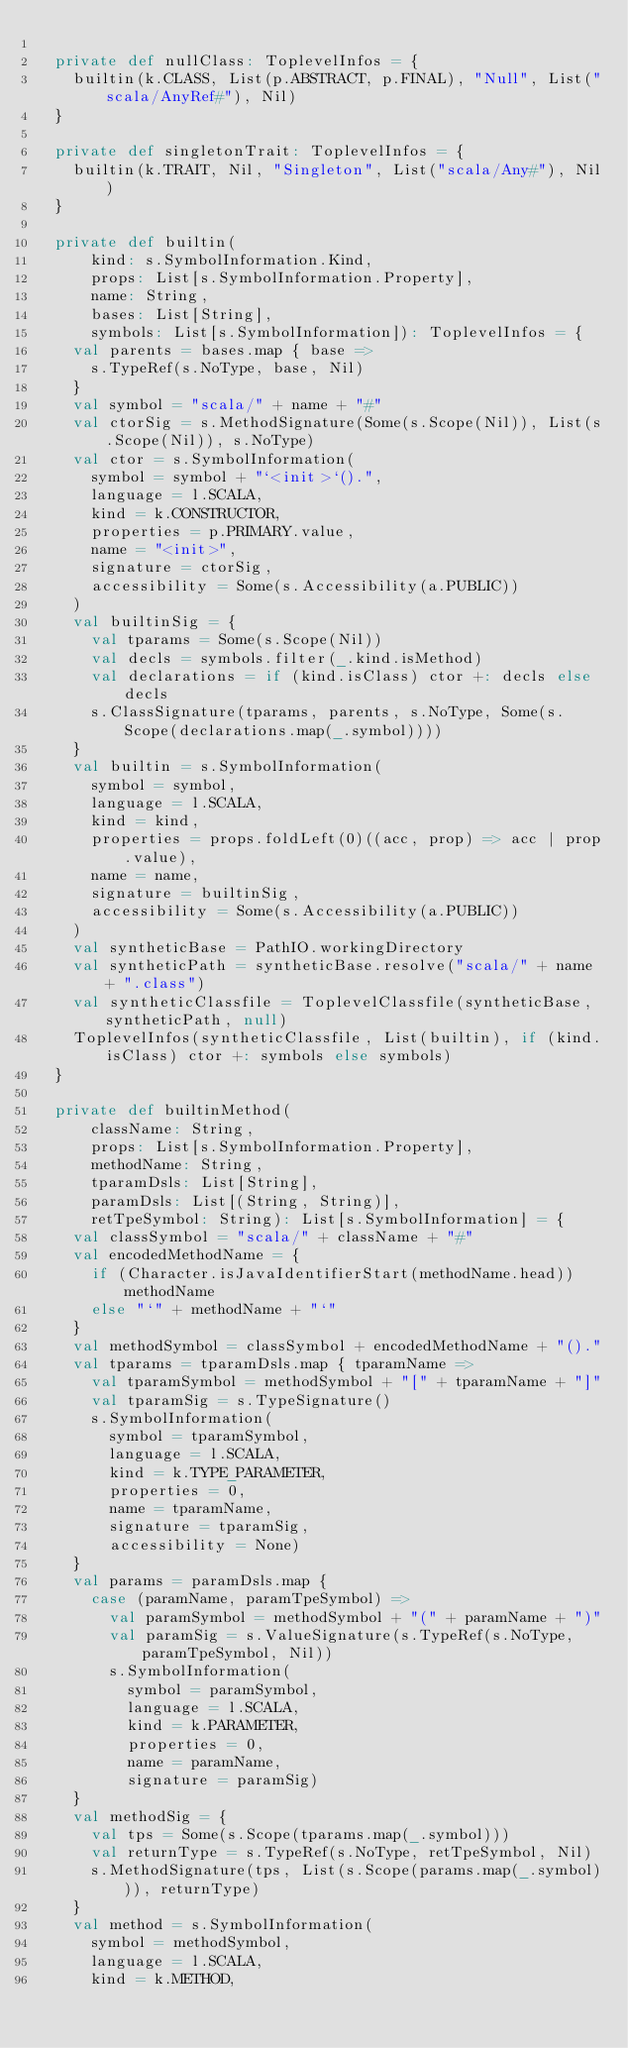Convert code to text. <code><loc_0><loc_0><loc_500><loc_500><_Scala_>
  private def nullClass: ToplevelInfos = {
    builtin(k.CLASS, List(p.ABSTRACT, p.FINAL), "Null", List("scala/AnyRef#"), Nil)
  }

  private def singletonTrait: ToplevelInfos = {
    builtin(k.TRAIT, Nil, "Singleton", List("scala/Any#"), Nil)
  }

  private def builtin(
      kind: s.SymbolInformation.Kind,
      props: List[s.SymbolInformation.Property],
      name: String,
      bases: List[String],
      symbols: List[s.SymbolInformation]): ToplevelInfos = {
    val parents = bases.map { base =>
      s.TypeRef(s.NoType, base, Nil)
    }
    val symbol = "scala/" + name + "#"
    val ctorSig = s.MethodSignature(Some(s.Scope(Nil)), List(s.Scope(Nil)), s.NoType)
    val ctor = s.SymbolInformation(
      symbol = symbol + "`<init>`().",
      language = l.SCALA,
      kind = k.CONSTRUCTOR,
      properties = p.PRIMARY.value,
      name = "<init>",
      signature = ctorSig,
      accessibility = Some(s.Accessibility(a.PUBLIC))
    )
    val builtinSig = {
      val tparams = Some(s.Scope(Nil))
      val decls = symbols.filter(_.kind.isMethod)
      val declarations = if (kind.isClass) ctor +: decls else decls
      s.ClassSignature(tparams, parents, s.NoType, Some(s.Scope(declarations.map(_.symbol))))
    }
    val builtin = s.SymbolInformation(
      symbol = symbol,
      language = l.SCALA,
      kind = kind,
      properties = props.foldLeft(0)((acc, prop) => acc | prop.value),
      name = name,
      signature = builtinSig,
      accessibility = Some(s.Accessibility(a.PUBLIC))
    )
    val syntheticBase = PathIO.workingDirectory
    val syntheticPath = syntheticBase.resolve("scala/" + name + ".class")
    val syntheticClassfile = ToplevelClassfile(syntheticBase, syntheticPath, null)
    ToplevelInfos(syntheticClassfile, List(builtin), if (kind.isClass) ctor +: symbols else symbols)
  }

  private def builtinMethod(
      className: String,
      props: List[s.SymbolInformation.Property],
      methodName: String,
      tparamDsls: List[String],
      paramDsls: List[(String, String)],
      retTpeSymbol: String): List[s.SymbolInformation] = {
    val classSymbol = "scala/" + className + "#"
    val encodedMethodName = {
      if (Character.isJavaIdentifierStart(methodName.head)) methodName
      else "`" + methodName + "`"
    }
    val methodSymbol = classSymbol + encodedMethodName + "()."
    val tparams = tparamDsls.map { tparamName =>
      val tparamSymbol = methodSymbol + "[" + tparamName + "]"
      val tparamSig = s.TypeSignature()
      s.SymbolInformation(
        symbol = tparamSymbol,
        language = l.SCALA,
        kind = k.TYPE_PARAMETER,
        properties = 0,
        name = tparamName,
        signature = tparamSig,
        accessibility = None)
    }
    val params = paramDsls.map {
      case (paramName, paramTpeSymbol) =>
        val paramSymbol = methodSymbol + "(" + paramName + ")"
        val paramSig = s.ValueSignature(s.TypeRef(s.NoType, paramTpeSymbol, Nil))
        s.SymbolInformation(
          symbol = paramSymbol,
          language = l.SCALA,
          kind = k.PARAMETER,
          properties = 0,
          name = paramName,
          signature = paramSig)
    }
    val methodSig = {
      val tps = Some(s.Scope(tparams.map(_.symbol)))
      val returnType = s.TypeRef(s.NoType, retTpeSymbol, Nil)
      s.MethodSignature(tps, List(s.Scope(params.map(_.symbol))), returnType)
    }
    val method = s.SymbolInformation(
      symbol = methodSymbol,
      language = l.SCALA,
      kind = k.METHOD,</code> 